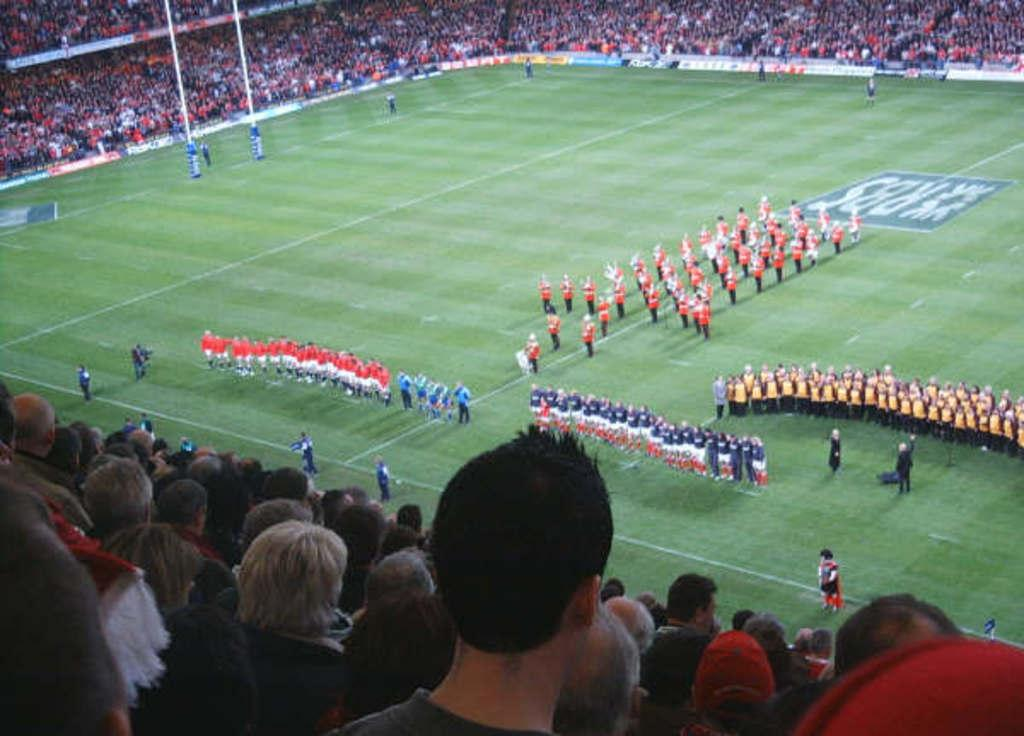What is the main activity taking place in the center of the image? There are many persons standing on the grass in the center of the image. What can be seen at the bottom of the image? There is a crowd at the bottom of the image. What is visible in the background of the image? In the background, there are chairs visible. Are there any other crowds in the image besides the one at the bottom? Yes, there is also a crowd in the background. What type of pain is the frog experiencing in the image? There is no frog present in the image, so it is not possible to determine if a frog is experiencing any pain. 